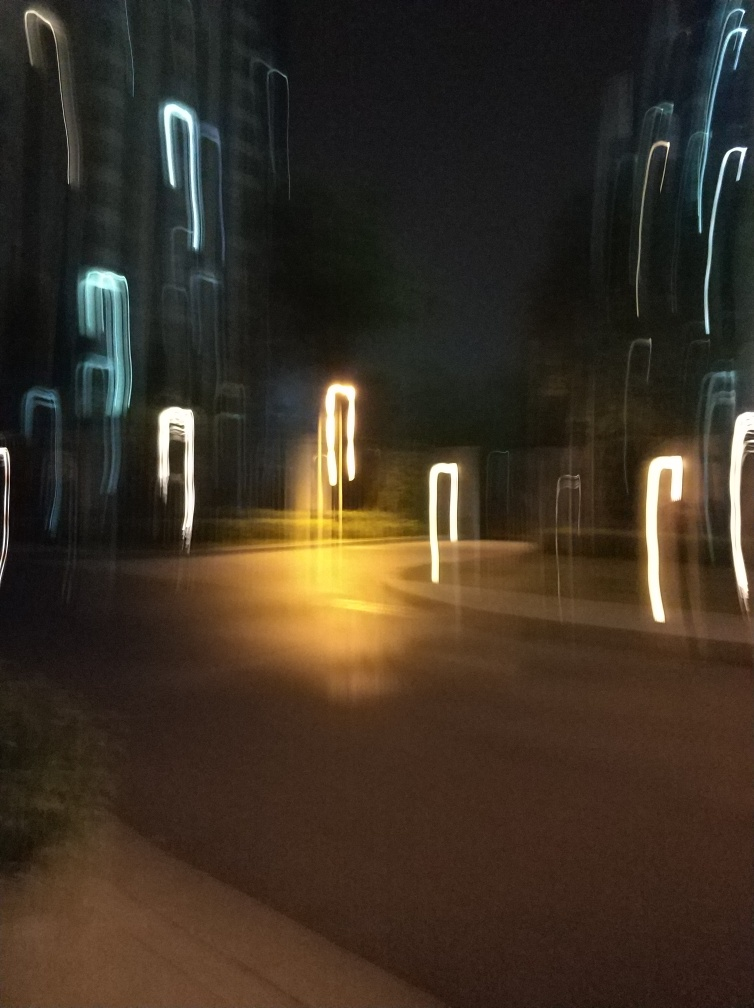Why are the colors not clear in this image?
A. The colors are vivid and vibrant.
B. The colors are not clear.
C. The colors are well-defined.
D. The colors are bright and beautiful.
Answer with the option's letter from the given choices directly.
 B. 